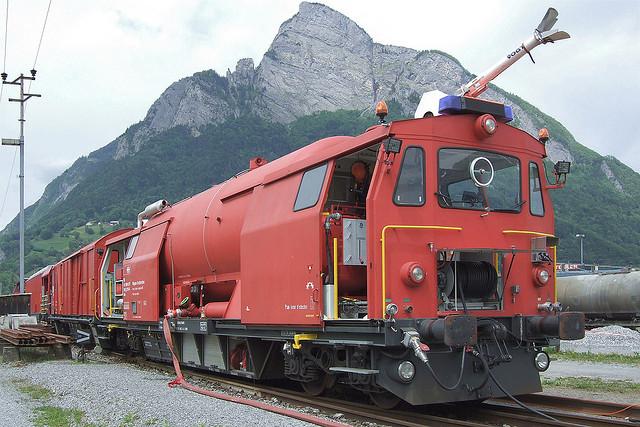Are there gravels along the rail?
Concise answer only. Yes. What is behind the train?
Concise answer only. Mountain. Is this a passenger train?
Quick response, please. No. 